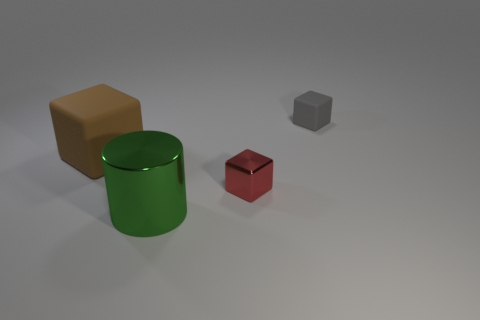What material do the objects look like they're made of? Based on their appearance and the way they reflect light, the large brown block and the red cube look like they could be made of rubber due to their matte surface. The green cylinder looks shiny and could be either plastic or metal, and the small grey cube has a dull finish which suggests it could be made of metal. 